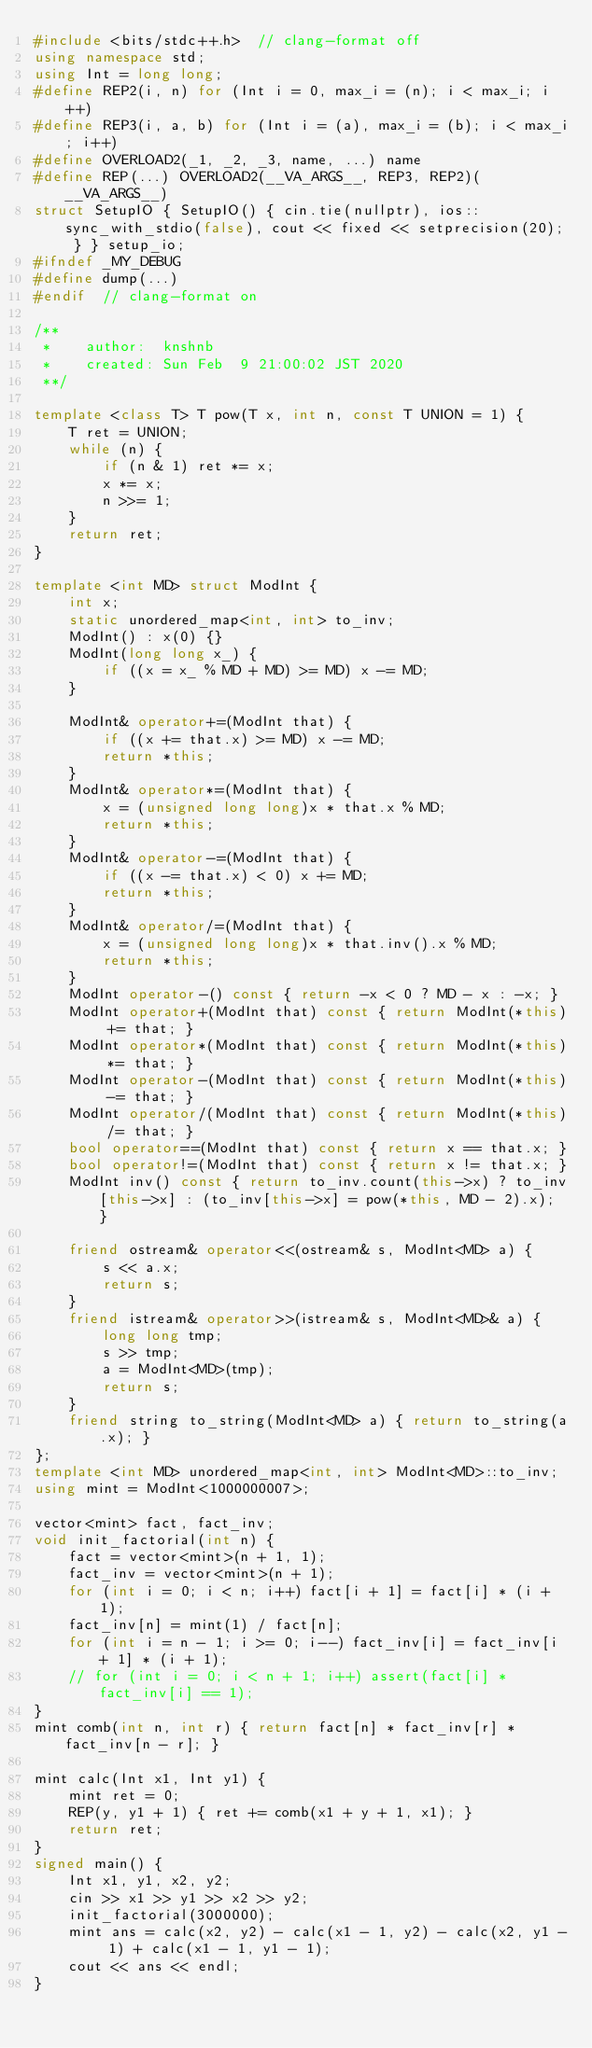<code> <loc_0><loc_0><loc_500><loc_500><_C++_>#include <bits/stdc++.h>  // clang-format off
using namespace std;
using Int = long long;
#define REP2(i, n) for (Int i = 0, max_i = (n); i < max_i; i++)
#define REP3(i, a, b) for (Int i = (a), max_i = (b); i < max_i; i++)
#define OVERLOAD2(_1, _2, _3, name, ...) name
#define REP(...) OVERLOAD2(__VA_ARGS__, REP3, REP2)(__VA_ARGS__)
struct SetupIO { SetupIO() { cin.tie(nullptr), ios::sync_with_stdio(false), cout << fixed << setprecision(20); } } setup_io;
#ifndef _MY_DEBUG
#define dump(...)
#endif  // clang-format on

/**
 *    author:  knshnb
 *    created: Sun Feb  9 21:00:02 JST 2020
 **/

template <class T> T pow(T x, int n, const T UNION = 1) {
    T ret = UNION;
    while (n) {
        if (n & 1) ret *= x;
        x *= x;
        n >>= 1;
    }
    return ret;
}

template <int MD> struct ModInt {
    int x;
    static unordered_map<int, int> to_inv;
    ModInt() : x(0) {}
    ModInt(long long x_) {
        if ((x = x_ % MD + MD) >= MD) x -= MD;
    }

    ModInt& operator+=(ModInt that) {
        if ((x += that.x) >= MD) x -= MD;
        return *this;
    }
    ModInt& operator*=(ModInt that) {
        x = (unsigned long long)x * that.x % MD;
        return *this;
    }
    ModInt& operator-=(ModInt that) {
        if ((x -= that.x) < 0) x += MD;
        return *this;
    }
    ModInt& operator/=(ModInt that) {
        x = (unsigned long long)x * that.inv().x % MD;
        return *this;
    }
    ModInt operator-() const { return -x < 0 ? MD - x : -x; }
    ModInt operator+(ModInt that) const { return ModInt(*this) += that; }
    ModInt operator*(ModInt that) const { return ModInt(*this) *= that; }
    ModInt operator-(ModInt that) const { return ModInt(*this) -= that; }
    ModInt operator/(ModInt that) const { return ModInt(*this) /= that; }
    bool operator==(ModInt that) const { return x == that.x; }
    bool operator!=(ModInt that) const { return x != that.x; }
    ModInt inv() const { return to_inv.count(this->x) ? to_inv[this->x] : (to_inv[this->x] = pow(*this, MD - 2).x); }

    friend ostream& operator<<(ostream& s, ModInt<MD> a) {
        s << a.x;
        return s;
    }
    friend istream& operator>>(istream& s, ModInt<MD>& a) {
        long long tmp;
        s >> tmp;
        a = ModInt<MD>(tmp);
        return s;
    }
    friend string to_string(ModInt<MD> a) { return to_string(a.x); }
};
template <int MD> unordered_map<int, int> ModInt<MD>::to_inv;
using mint = ModInt<1000000007>;

vector<mint> fact, fact_inv;
void init_factorial(int n) {
    fact = vector<mint>(n + 1, 1);
    fact_inv = vector<mint>(n + 1);
    for (int i = 0; i < n; i++) fact[i + 1] = fact[i] * (i + 1);
    fact_inv[n] = mint(1) / fact[n];
    for (int i = n - 1; i >= 0; i--) fact_inv[i] = fact_inv[i + 1] * (i + 1);
    // for (int i = 0; i < n + 1; i++) assert(fact[i] * fact_inv[i] == 1);
}
mint comb(int n, int r) { return fact[n] * fact_inv[r] * fact_inv[n - r]; }

mint calc(Int x1, Int y1) {
    mint ret = 0;
    REP(y, y1 + 1) { ret += comb(x1 + y + 1, x1); }
    return ret;
}
signed main() {
    Int x1, y1, x2, y2;
    cin >> x1 >> y1 >> x2 >> y2;
    init_factorial(3000000);
    mint ans = calc(x2, y2) - calc(x1 - 1, y2) - calc(x2, y1 - 1) + calc(x1 - 1, y1 - 1);
    cout << ans << endl;
}
</code> 